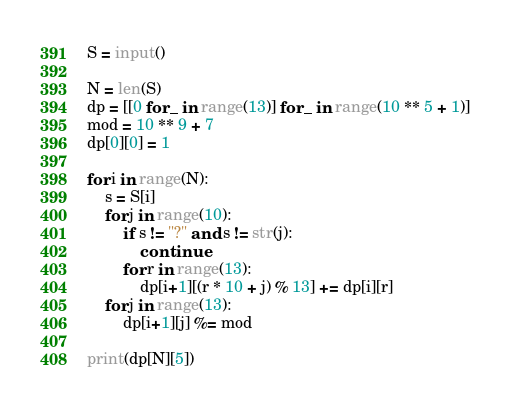Convert code to text. <code><loc_0><loc_0><loc_500><loc_500><_Python_>S = input()

N = len(S)
dp = [[0 for _ in range(13)] for _ in range(10 ** 5 + 1)]
mod = 10 ** 9 + 7
dp[0][0] = 1

for i in range(N):
    s = S[i]
    for j in range(10):
        if s != "?" and s != str(j):
            continue
        for r in range(13):
            dp[i+1][(r * 10 + j) % 13] += dp[i][r]
    for j in range(13):
        dp[i+1][j] %= mod

print(dp[N][5])
</code> 